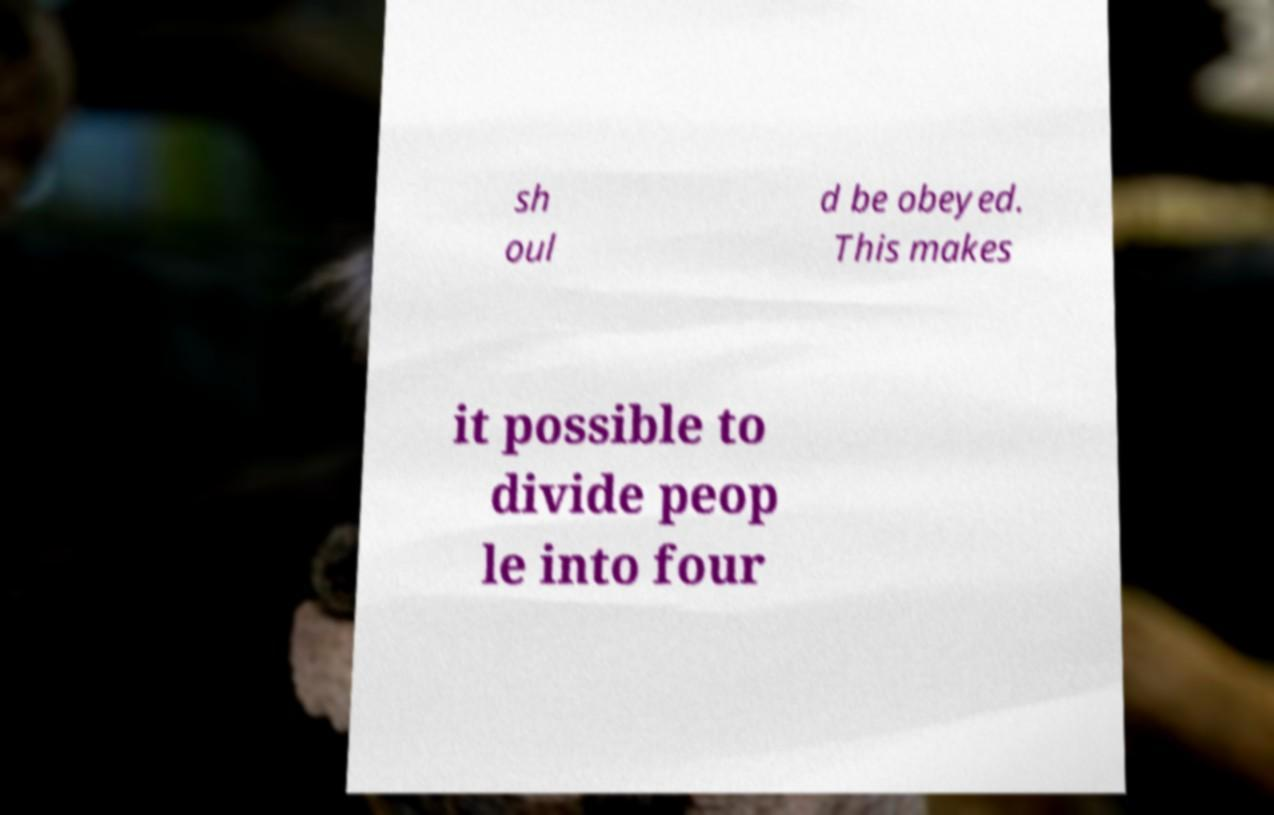What messages or text are displayed in this image? I need them in a readable, typed format. sh oul d be obeyed. This makes it possible to divide peop le into four 